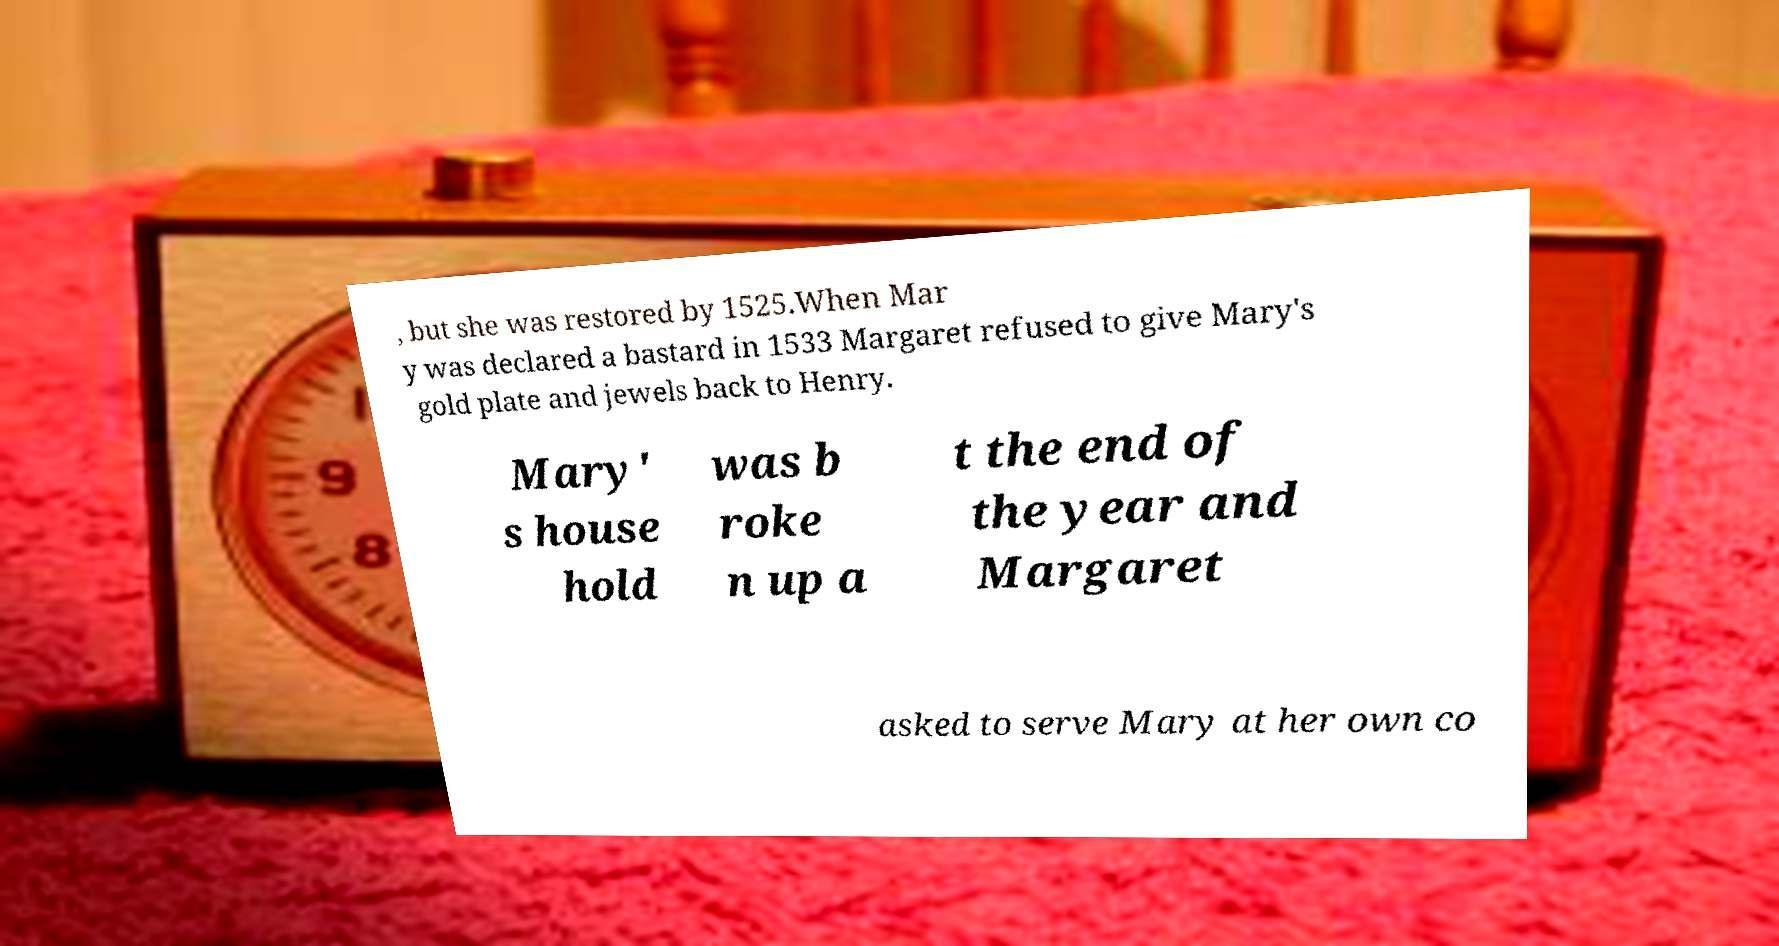Please identify and transcribe the text found in this image. , but she was restored by 1525.When Mar y was declared a bastard in 1533 Margaret refused to give Mary's gold plate and jewels back to Henry. Mary' s house hold was b roke n up a t the end of the year and Margaret asked to serve Mary at her own co 